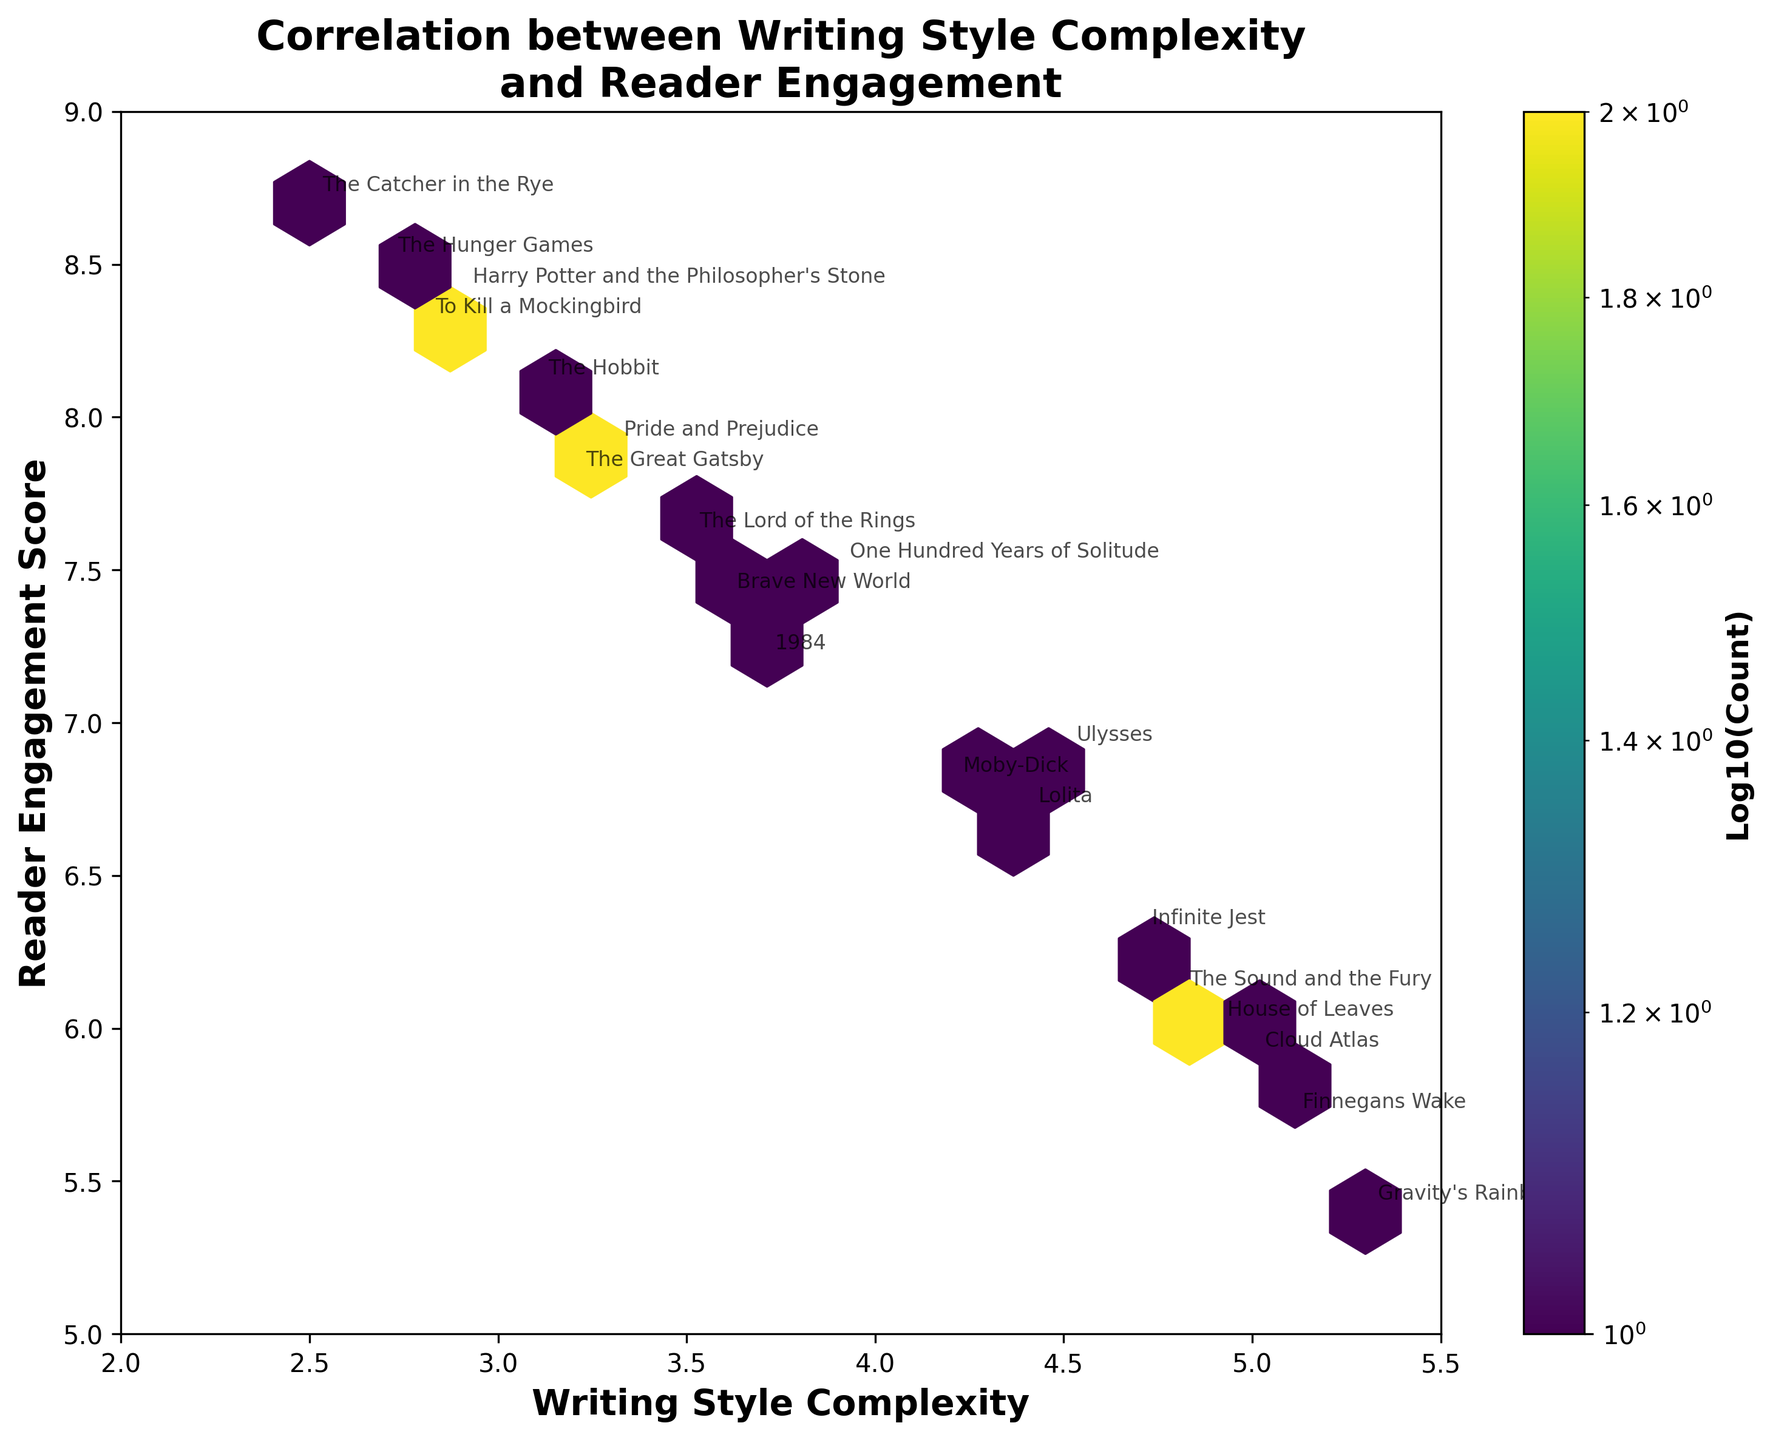what is the title of the plot? The title of the plot is written at the top of the figure in bold letters, which describes the main correlation being illustrated.
Answer: Correlation between Writing Style Complexity and Reader Engagement What is the x-axis label? The label for the x-axis is specified below the horizontal axis and describes the variable associated with that axis in bold text.
Answer: Writing Style Complexity How many literary works fall in the highest density hexbin region? By looking at the color legend and finding the most densely populated region in the hexbin plot, then counting the annotations within that specific region.
Answer: Three works Is there a trend between writing style complexity and reader engagement scores? By observing the diagonal spread of the data points, one can infer whether there is an increasing or decreasing trend in engagement with complexity.
Answer: General decreasing trend Which work has the highest reader engagement score? Look for the annotated point at the topmost part of the y-axis to identify the work with the highest engagement score.
Answer: The Catcher in the Rye Which work has the most complex writing style? Observe the rightmost point on the x-axis to identify the literary work with the highest writing style complexity.
Answer: Gravity's Rainbow What is the approximate reader engagement score for '1984'? Locate the label '1984' on the plot, then move horizontally to the y-axis to find the reader engagement score associated with that point.
Answer: 7.2 Which work is more complex, 'Moby-Dick' or 'To Kill a Mockingbird'? Compare the x-axis positions of both annotated points to determine which one is further to the right, indicating higher complexity.
Answer: Moby-Dick What is the relationship between 'The Great Gatsby' and 'Pride and Prejudice' in terms of reader engagement score? Find both works on the plot and compare their y-axis values to determine which has a higher engagement score.
Answer: Pride and Prejudice is slightly higher Is 'One Hundred Years of Solitude' closer to the high or low density region? Locate 'One Hundred Years of Solitude' on the plot and identify the color of the hexbin it falls in to determine density.
Answer: Moderate density 